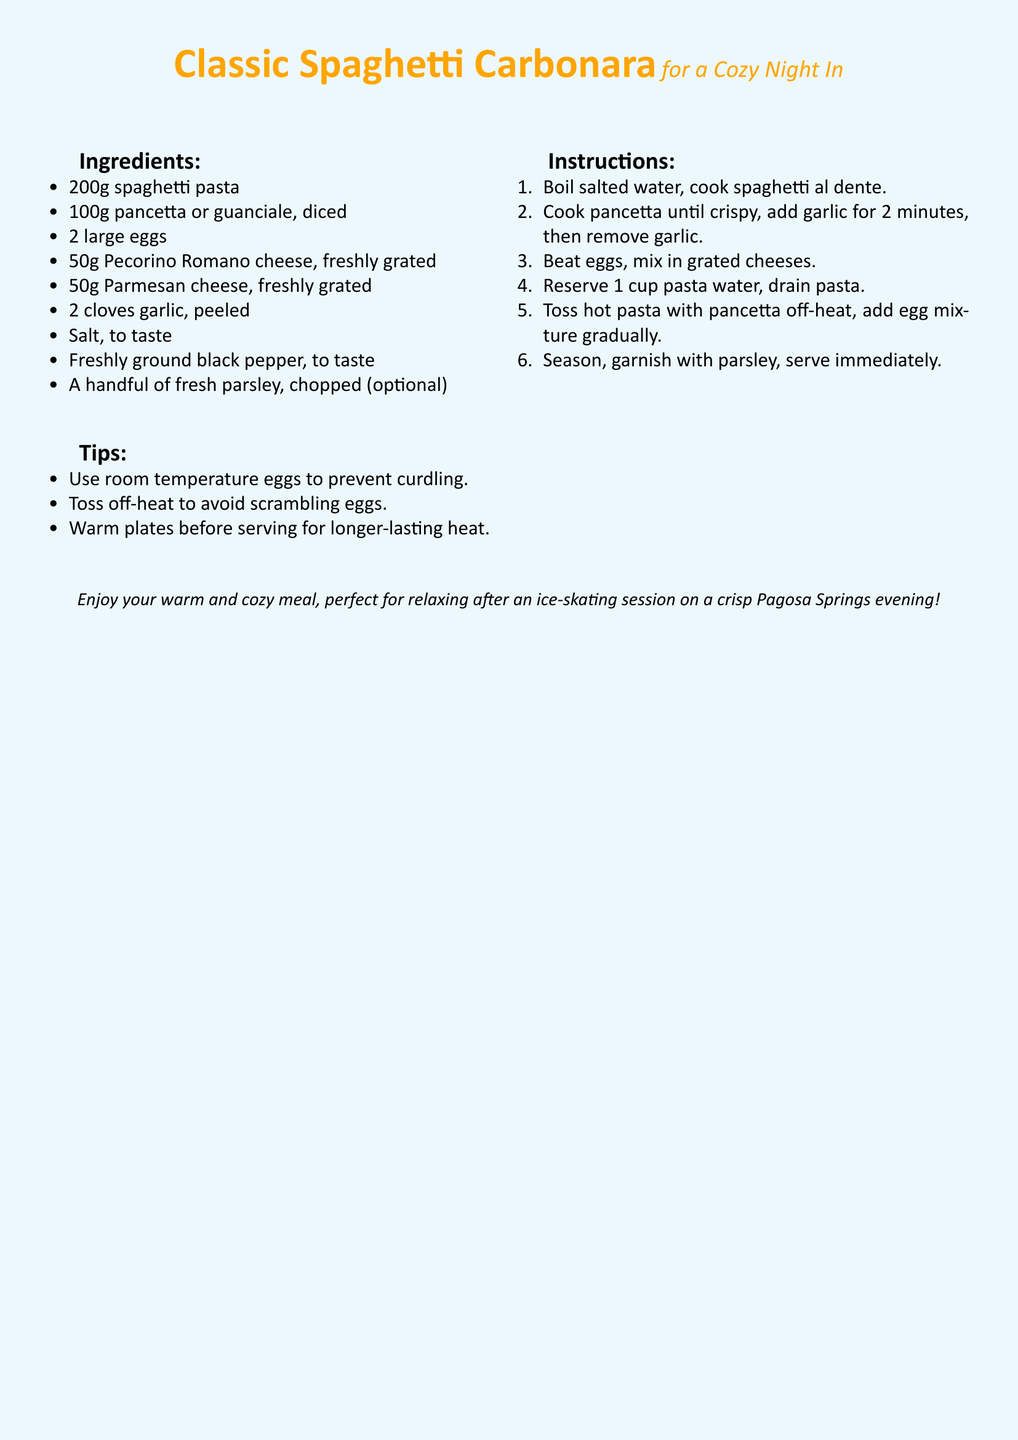What are the two types of cheese used? The document specifies Pecorino Romano and Parmesan cheese as the two types of cheese used in the recipe.
Answer: Pecorino Romano, Parmesan How much spaghetti pasta is needed? The recipe indicates that 200g of spaghetti pasta is required.
Answer: 200g What should be done to prevent eggs from scrambling? The recipe suggests tossing the pasta off-heat to avoid scrambling the eggs during the mixing process.
Answer: Toss off-heat What is the cooking method for the pancetta? The instructions specify cooking the pancetta until it is crispy.
Answer: Cook until crispy How many cloves of garlic are used in the recipe? The document states that 2 cloves of garlic are included in the ingredients list.
Answer: 2 cloves What is a way to keep the meal warm before serving? The tips mention warming the plates before serving to help maintain the heat of the meal.
Answer: Warm plates How many steps are there in the instructions? The instructions section contains a total of 6 steps described in the recipe.
Answer: 6 steps What is a suggested garnish for the dish? The recipe advises using a handful of fresh parsley, chopped, as an optional garnish.
Answer: Fresh parsley 